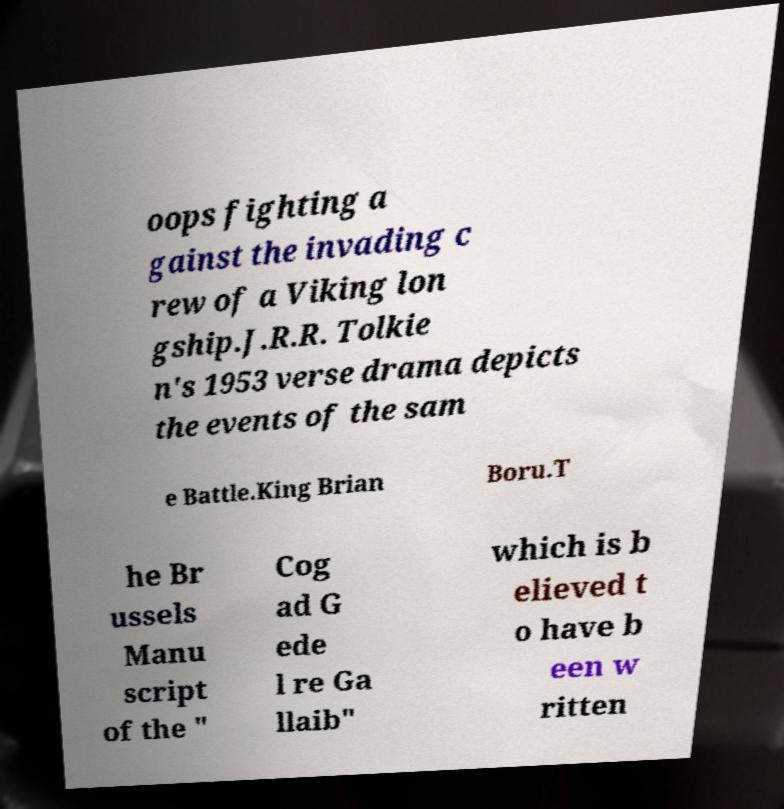There's text embedded in this image that I need extracted. Can you transcribe it verbatim? oops fighting a gainst the invading c rew of a Viking lon gship.J.R.R. Tolkie n's 1953 verse drama depicts the events of the sam e Battle.King Brian Boru.T he Br ussels Manu script of the " Cog ad G ede l re Ga llaib" which is b elieved t o have b een w ritten 